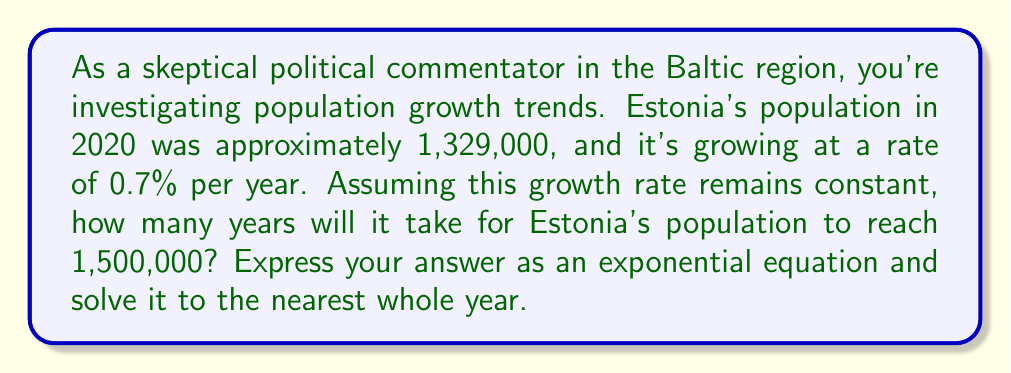Could you help me with this problem? To solve this problem, we'll use the exponential growth formula:

$$A = P(1 + r)^t$$

Where:
$A$ = final amount (target population)
$P$ = initial amount (initial population)
$r$ = growth rate (as a decimal)
$t$ = time (in years)

Given:
$A = 1,500,000$
$P = 1,329,000$
$r = 0.007$ (0.7% expressed as a decimal)

Let's substitute these values into the equation:

$$1,500,000 = 1,329,000(1 + 0.007)^t$$

Now, we need to solve for $t$:

1. Divide both sides by 1,329,000:
   $$\frac{1,500,000}{1,329,000} = (1.007)^t$$

2. Take the natural log of both sides:
   $$\ln(\frac{1,500,000}{1,329,000}) = t \ln(1.007)$$

3. Solve for $t$:
   $$t = \frac{\ln(\frac{1,500,000}{1,329,000})}{\ln(1.007)}$$

4. Use a calculator to evaluate:
   $$t \approx 17.96$$

5. Round to the nearest whole year:
   $t = 18$ years
Answer: It will take approximately 18 years for Estonia's population to reach 1,500,000, assuming a constant growth rate of 0.7% per year. 